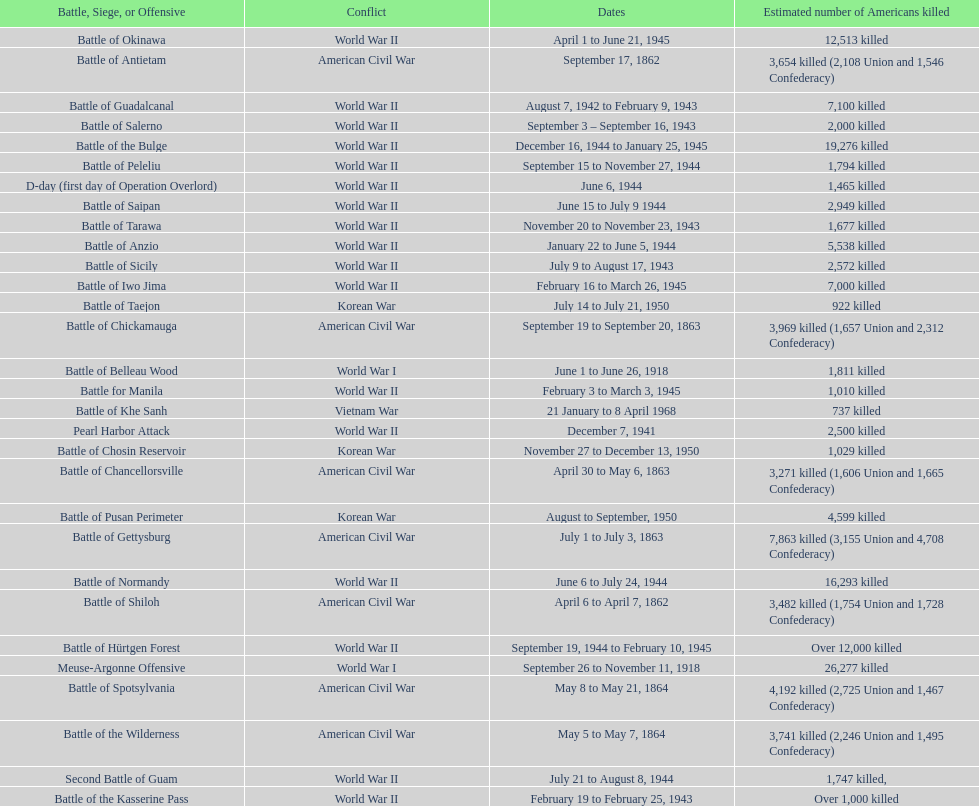How many battles resulted between 3,000 and 4,200 estimated americans killed? 6. 